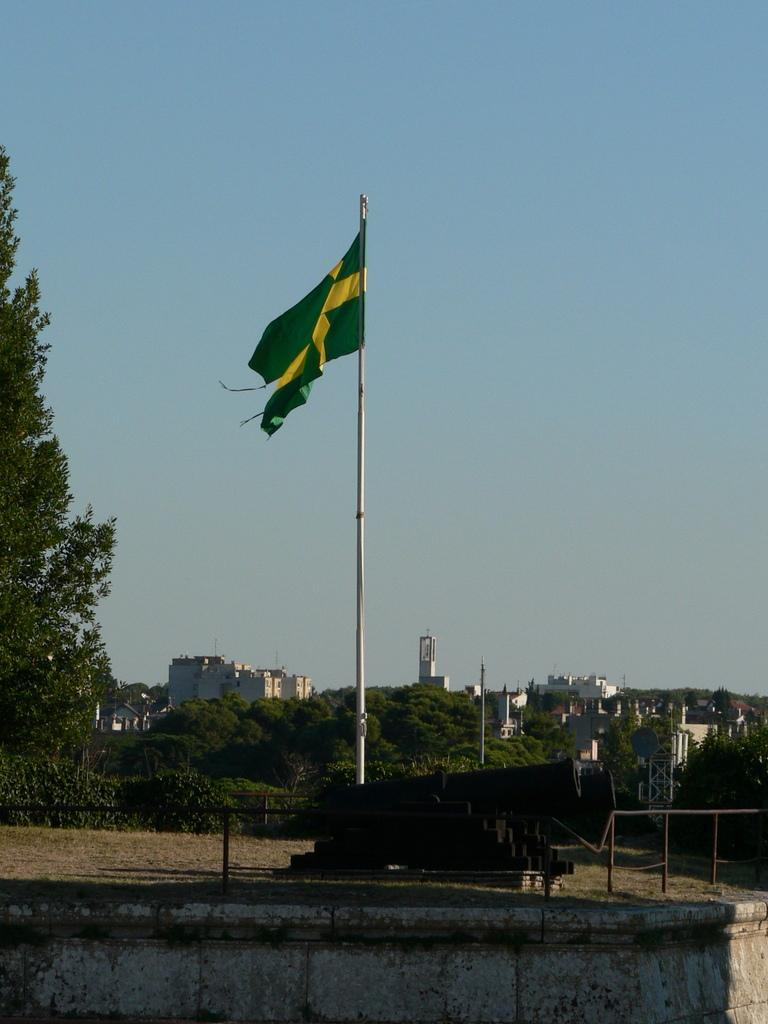What is the main subject in the center of the image? There is a flag in the center of the image. What can be seen in the background of the image? Railings, trees, buildings, and poles are visible in the background of the image. What is visible at the top of the image? The sky is visible at the top of the image. How many pizzas are being fought over by the bees in the image? There are no bees or pizzas present in the image. What type of fight is taking place between the bees and the pizzas in the image? There is no fight between bees and pizzas in the image, as neither bees nor pizzas are present. 